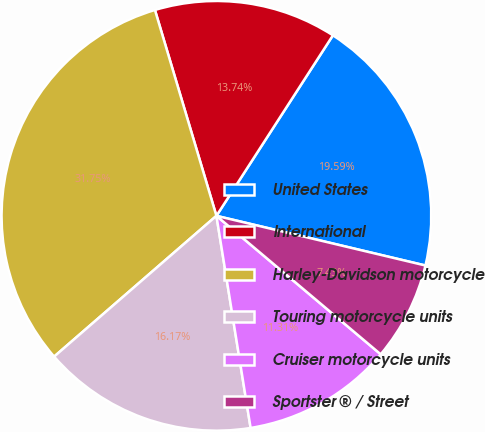<chart> <loc_0><loc_0><loc_500><loc_500><pie_chart><fcel>United States<fcel>International<fcel>Harley-Davidson motorcycle<fcel>Touring motorcycle units<fcel>Cruiser motorcycle units<fcel>Sportster ® / Street<nl><fcel>19.59%<fcel>13.74%<fcel>31.75%<fcel>16.17%<fcel>11.31%<fcel>7.43%<nl></chart> 